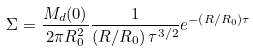<formula> <loc_0><loc_0><loc_500><loc_500>\Sigma = \frac { M _ { d } ( 0 ) } { 2 \pi R _ { 0 } ^ { 2 } } \frac { 1 } { \left ( R / R _ { 0 } \right ) \tau ^ { 3 / 2 } } e ^ { - \left ( R / R _ { 0 } \right ) \tau }</formula> 